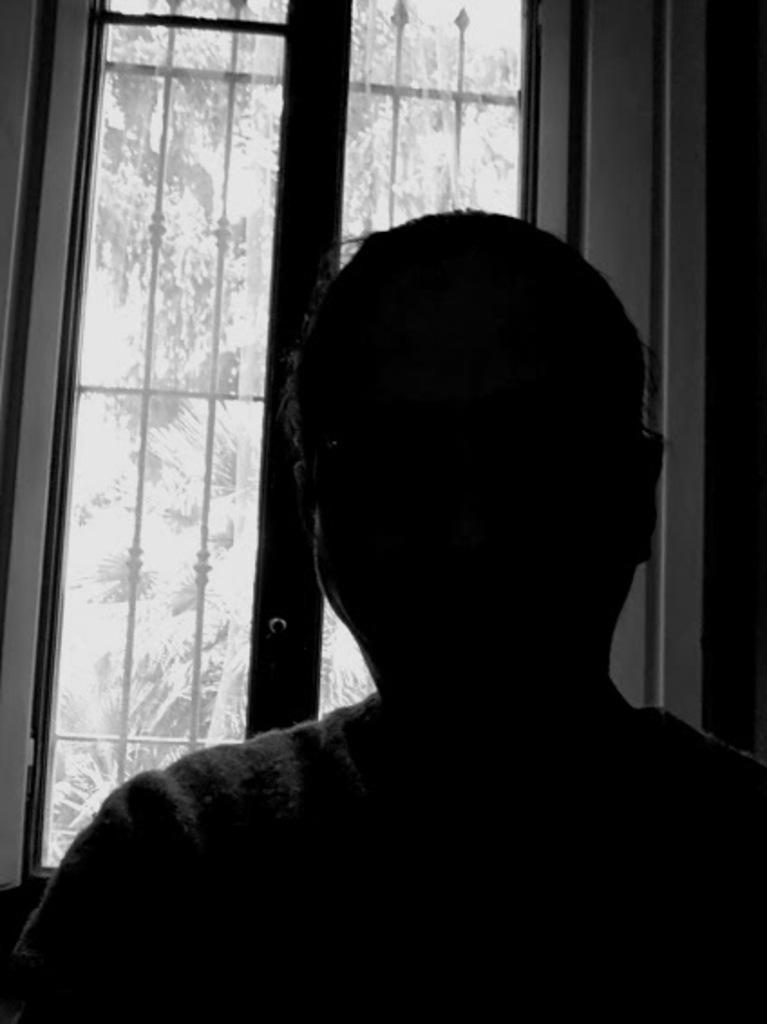Could you give a brief overview of what you see in this image? Here in this picture we can see a person present over there and behind him we can see a window present , through which we can see trees over there. 